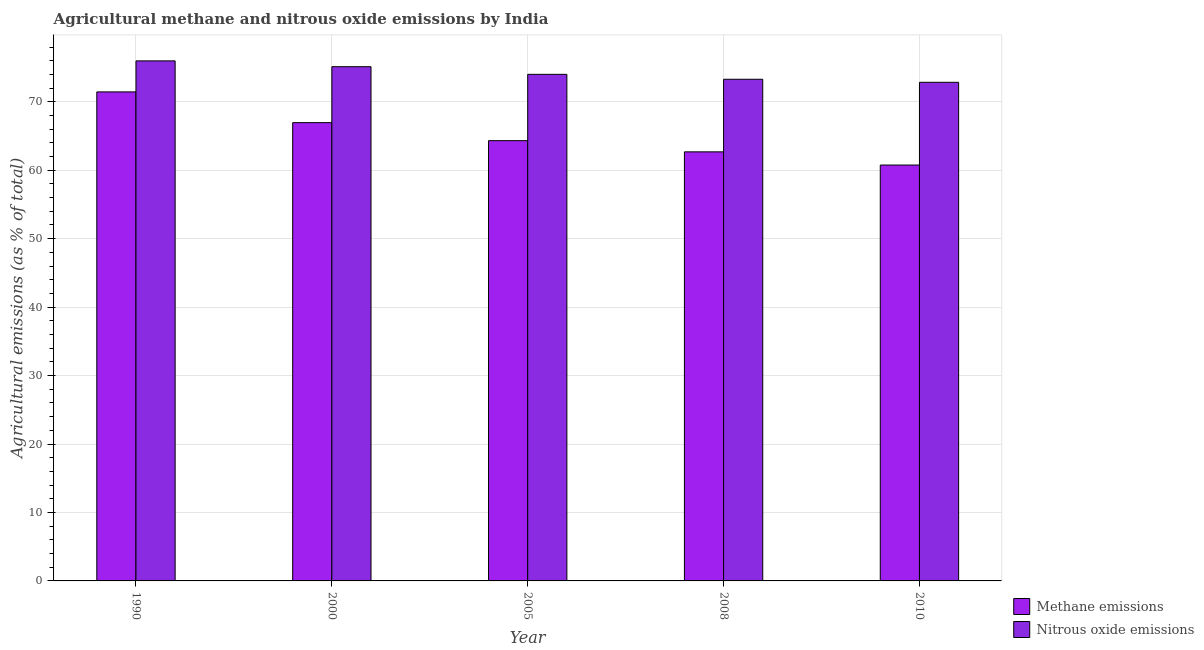How many groups of bars are there?
Keep it short and to the point. 5. Are the number of bars per tick equal to the number of legend labels?
Make the answer very short. Yes. Are the number of bars on each tick of the X-axis equal?
Ensure brevity in your answer.  Yes. How many bars are there on the 2nd tick from the right?
Keep it short and to the point. 2. What is the label of the 4th group of bars from the left?
Offer a very short reply. 2008. In how many cases, is the number of bars for a given year not equal to the number of legend labels?
Provide a succinct answer. 0. What is the amount of methane emissions in 2010?
Your answer should be very brief. 60.76. Across all years, what is the maximum amount of methane emissions?
Your response must be concise. 71.44. Across all years, what is the minimum amount of nitrous oxide emissions?
Offer a terse response. 72.84. In which year was the amount of nitrous oxide emissions maximum?
Offer a very short reply. 1990. What is the total amount of methane emissions in the graph?
Keep it short and to the point. 326.15. What is the difference between the amount of methane emissions in 1990 and that in 2008?
Offer a terse response. 8.76. What is the difference between the amount of nitrous oxide emissions in 1990 and the amount of methane emissions in 2010?
Offer a terse response. 3.13. What is the average amount of nitrous oxide emissions per year?
Your response must be concise. 74.25. In the year 2010, what is the difference between the amount of nitrous oxide emissions and amount of methane emissions?
Your response must be concise. 0. What is the ratio of the amount of nitrous oxide emissions in 2005 to that in 2008?
Provide a short and direct response. 1.01. Is the amount of nitrous oxide emissions in 1990 less than that in 2000?
Your answer should be compact. No. What is the difference between the highest and the second highest amount of methane emissions?
Make the answer very short. 4.49. What is the difference between the highest and the lowest amount of nitrous oxide emissions?
Make the answer very short. 3.13. In how many years, is the amount of methane emissions greater than the average amount of methane emissions taken over all years?
Offer a very short reply. 2. What does the 1st bar from the left in 2000 represents?
Give a very brief answer. Methane emissions. What does the 2nd bar from the right in 2010 represents?
Ensure brevity in your answer.  Methane emissions. How many bars are there?
Make the answer very short. 10. Are all the bars in the graph horizontal?
Your response must be concise. No. How many years are there in the graph?
Offer a very short reply. 5. What is the difference between two consecutive major ticks on the Y-axis?
Make the answer very short. 10. Does the graph contain grids?
Offer a very short reply. Yes. Where does the legend appear in the graph?
Keep it short and to the point. Bottom right. How many legend labels are there?
Offer a very short reply. 2. What is the title of the graph?
Provide a succinct answer. Agricultural methane and nitrous oxide emissions by India. Does "Health Care" appear as one of the legend labels in the graph?
Provide a short and direct response. No. What is the label or title of the X-axis?
Make the answer very short. Year. What is the label or title of the Y-axis?
Offer a terse response. Agricultural emissions (as % of total). What is the Agricultural emissions (as % of total) in Methane emissions in 1990?
Keep it short and to the point. 71.44. What is the Agricultural emissions (as % of total) in Nitrous oxide emissions in 1990?
Provide a succinct answer. 75.97. What is the Agricultural emissions (as % of total) in Methane emissions in 2000?
Give a very brief answer. 66.95. What is the Agricultural emissions (as % of total) in Nitrous oxide emissions in 2000?
Keep it short and to the point. 75.12. What is the Agricultural emissions (as % of total) of Methane emissions in 2005?
Offer a terse response. 64.32. What is the Agricultural emissions (as % of total) of Nitrous oxide emissions in 2005?
Your answer should be compact. 74.01. What is the Agricultural emissions (as % of total) in Methane emissions in 2008?
Your response must be concise. 62.68. What is the Agricultural emissions (as % of total) of Nitrous oxide emissions in 2008?
Make the answer very short. 73.29. What is the Agricultural emissions (as % of total) of Methane emissions in 2010?
Your response must be concise. 60.76. What is the Agricultural emissions (as % of total) in Nitrous oxide emissions in 2010?
Provide a succinct answer. 72.84. Across all years, what is the maximum Agricultural emissions (as % of total) of Methane emissions?
Make the answer very short. 71.44. Across all years, what is the maximum Agricultural emissions (as % of total) of Nitrous oxide emissions?
Ensure brevity in your answer.  75.97. Across all years, what is the minimum Agricultural emissions (as % of total) in Methane emissions?
Offer a terse response. 60.76. Across all years, what is the minimum Agricultural emissions (as % of total) of Nitrous oxide emissions?
Give a very brief answer. 72.84. What is the total Agricultural emissions (as % of total) of Methane emissions in the graph?
Your answer should be compact. 326.15. What is the total Agricultural emissions (as % of total) in Nitrous oxide emissions in the graph?
Make the answer very short. 371.23. What is the difference between the Agricultural emissions (as % of total) in Methane emissions in 1990 and that in 2000?
Give a very brief answer. 4.49. What is the difference between the Agricultural emissions (as % of total) in Nitrous oxide emissions in 1990 and that in 2000?
Provide a succinct answer. 0.85. What is the difference between the Agricultural emissions (as % of total) of Methane emissions in 1990 and that in 2005?
Ensure brevity in your answer.  7.12. What is the difference between the Agricultural emissions (as % of total) in Nitrous oxide emissions in 1990 and that in 2005?
Keep it short and to the point. 1.97. What is the difference between the Agricultural emissions (as % of total) in Methane emissions in 1990 and that in 2008?
Your answer should be compact. 8.76. What is the difference between the Agricultural emissions (as % of total) of Nitrous oxide emissions in 1990 and that in 2008?
Offer a very short reply. 2.69. What is the difference between the Agricultural emissions (as % of total) in Methane emissions in 1990 and that in 2010?
Give a very brief answer. 10.68. What is the difference between the Agricultural emissions (as % of total) in Nitrous oxide emissions in 1990 and that in 2010?
Give a very brief answer. 3.13. What is the difference between the Agricultural emissions (as % of total) in Methane emissions in 2000 and that in 2005?
Make the answer very short. 2.64. What is the difference between the Agricultural emissions (as % of total) of Nitrous oxide emissions in 2000 and that in 2005?
Your response must be concise. 1.12. What is the difference between the Agricultural emissions (as % of total) of Methane emissions in 2000 and that in 2008?
Your answer should be very brief. 4.27. What is the difference between the Agricultural emissions (as % of total) in Nitrous oxide emissions in 2000 and that in 2008?
Provide a short and direct response. 1.84. What is the difference between the Agricultural emissions (as % of total) in Methane emissions in 2000 and that in 2010?
Offer a terse response. 6.2. What is the difference between the Agricultural emissions (as % of total) of Nitrous oxide emissions in 2000 and that in 2010?
Make the answer very short. 2.28. What is the difference between the Agricultural emissions (as % of total) in Methane emissions in 2005 and that in 2008?
Offer a terse response. 1.63. What is the difference between the Agricultural emissions (as % of total) of Nitrous oxide emissions in 2005 and that in 2008?
Your answer should be compact. 0.72. What is the difference between the Agricultural emissions (as % of total) in Methane emissions in 2005 and that in 2010?
Offer a terse response. 3.56. What is the difference between the Agricultural emissions (as % of total) of Nitrous oxide emissions in 2005 and that in 2010?
Provide a short and direct response. 1.16. What is the difference between the Agricultural emissions (as % of total) of Methane emissions in 2008 and that in 2010?
Provide a succinct answer. 1.93. What is the difference between the Agricultural emissions (as % of total) of Nitrous oxide emissions in 2008 and that in 2010?
Provide a succinct answer. 0.44. What is the difference between the Agricultural emissions (as % of total) in Methane emissions in 1990 and the Agricultural emissions (as % of total) in Nitrous oxide emissions in 2000?
Your answer should be compact. -3.68. What is the difference between the Agricultural emissions (as % of total) of Methane emissions in 1990 and the Agricultural emissions (as % of total) of Nitrous oxide emissions in 2005?
Your response must be concise. -2.57. What is the difference between the Agricultural emissions (as % of total) of Methane emissions in 1990 and the Agricultural emissions (as % of total) of Nitrous oxide emissions in 2008?
Make the answer very short. -1.85. What is the difference between the Agricultural emissions (as % of total) of Methane emissions in 1990 and the Agricultural emissions (as % of total) of Nitrous oxide emissions in 2010?
Provide a succinct answer. -1.4. What is the difference between the Agricultural emissions (as % of total) in Methane emissions in 2000 and the Agricultural emissions (as % of total) in Nitrous oxide emissions in 2005?
Offer a terse response. -7.06. What is the difference between the Agricultural emissions (as % of total) in Methane emissions in 2000 and the Agricultural emissions (as % of total) in Nitrous oxide emissions in 2008?
Provide a succinct answer. -6.33. What is the difference between the Agricultural emissions (as % of total) of Methane emissions in 2000 and the Agricultural emissions (as % of total) of Nitrous oxide emissions in 2010?
Keep it short and to the point. -5.89. What is the difference between the Agricultural emissions (as % of total) in Methane emissions in 2005 and the Agricultural emissions (as % of total) in Nitrous oxide emissions in 2008?
Your response must be concise. -8.97. What is the difference between the Agricultural emissions (as % of total) in Methane emissions in 2005 and the Agricultural emissions (as % of total) in Nitrous oxide emissions in 2010?
Your answer should be compact. -8.53. What is the difference between the Agricultural emissions (as % of total) in Methane emissions in 2008 and the Agricultural emissions (as % of total) in Nitrous oxide emissions in 2010?
Provide a succinct answer. -10.16. What is the average Agricultural emissions (as % of total) of Methane emissions per year?
Keep it short and to the point. 65.23. What is the average Agricultural emissions (as % of total) in Nitrous oxide emissions per year?
Offer a very short reply. 74.25. In the year 1990, what is the difference between the Agricultural emissions (as % of total) in Methane emissions and Agricultural emissions (as % of total) in Nitrous oxide emissions?
Provide a short and direct response. -4.53. In the year 2000, what is the difference between the Agricultural emissions (as % of total) in Methane emissions and Agricultural emissions (as % of total) in Nitrous oxide emissions?
Make the answer very short. -8.17. In the year 2005, what is the difference between the Agricultural emissions (as % of total) of Methane emissions and Agricultural emissions (as % of total) of Nitrous oxide emissions?
Provide a succinct answer. -9.69. In the year 2008, what is the difference between the Agricultural emissions (as % of total) in Methane emissions and Agricultural emissions (as % of total) in Nitrous oxide emissions?
Offer a very short reply. -10.6. In the year 2010, what is the difference between the Agricultural emissions (as % of total) of Methane emissions and Agricultural emissions (as % of total) of Nitrous oxide emissions?
Offer a very short reply. -12.09. What is the ratio of the Agricultural emissions (as % of total) in Methane emissions in 1990 to that in 2000?
Offer a terse response. 1.07. What is the ratio of the Agricultural emissions (as % of total) of Nitrous oxide emissions in 1990 to that in 2000?
Your response must be concise. 1.01. What is the ratio of the Agricultural emissions (as % of total) of Methane emissions in 1990 to that in 2005?
Offer a terse response. 1.11. What is the ratio of the Agricultural emissions (as % of total) in Nitrous oxide emissions in 1990 to that in 2005?
Ensure brevity in your answer.  1.03. What is the ratio of the Agricultural emissions (as % of total) in Methane emissions in 1990 to that in 2008?
Provide a succinct answer. 1.14. What is the ratio of the Agricultural emissions (as % of total) of Nitrous oxide emissions in 1990 to that in 2008?
Ensure brevity in your answer.  1.04. What is the ratio of the Agricultural emissions (as % of total) in Methane emissions in 1990 to that in 2010?
Your answer should be compact. 1.18. What is the ratio of the Agricultural emissions (as % of total) of Nitrous oxide emissions in 1990 to that in 2010?
Provide a short and direct response. 1.04. What is the ratio of the Agricultural emissions (as % of total) of Methane emissions in 2000 to that in 2005?
Ensure brevity in your answer.  1.04. What is the ratio of the Agricultural emissions (as % of total) of Nitrous oxide emissions in 2000 to that in 2005?
Your response must be concise. 1.02. What is the ratio of the Agricultural emissions (as % of total) in Methane emissions in 2000 to that in 2008?
Make the answer very short. 1.07. What is the ratio of the Agricultural emissions (as % of total) in Nitrous oxide emissions in 2000 to that in 2008?
Offer a very short reply. 1.03. What is the ratio of the Agricultural emissions (as % of total) of Methane emissions in 2000 to that in 2010?
Offer a very short reply. 1.1. What is the ratio of the Agricultural emissions (as % of total) of Nitrous oxide emissions in 2000 to that in 2010?
Your answer should be compact. 1.03. What is the ratio of the Agricultural emissions (as % of total) of Methane emissions in 2005 to that in 2008?
Keep it short and to the point. 1.03. What is the ratio of the Agricultural emissions (as % of total) in Nitrous oxide emissions in 2005 to that in 2008?
Offer a terse response. 1.01. What is the ratio of the Agricultural emissions (as % of total) of Methane emissions in 2005 to that in 2010?
Give a very brief answer. 1.06. What is the ratio of the Agricultural emissions (as % of total) in Nitrous oxide emissions in 2005 to that in 2010?
Your answer should be very brief. 1.02. What is the ratio of the Agricultural emissions (as % of total) of Methane emissions in 2008 to that in 2010?
Ensure brevity in your answer.  1.03. What is the difference between the highest and the second highest Agricultural emissions (as % of total) of Methane emissions?
Provide a short and direct response. 4.49. What is the difference between the highest and the second highest Agricultural emissions (as % of total) of Nitrous oxide emissions?
Make the answer very short. 0.85. What is the difference between the highest and the lowest Agricultural emissions (as % of total) in Methane emissions?
Offer a terse response. 10.68. What is the difference between the highest and the lowest Agricultural emissions (as % of total) of Nitrous oxide emissions?
Provide a short and direct response. 3.13. 